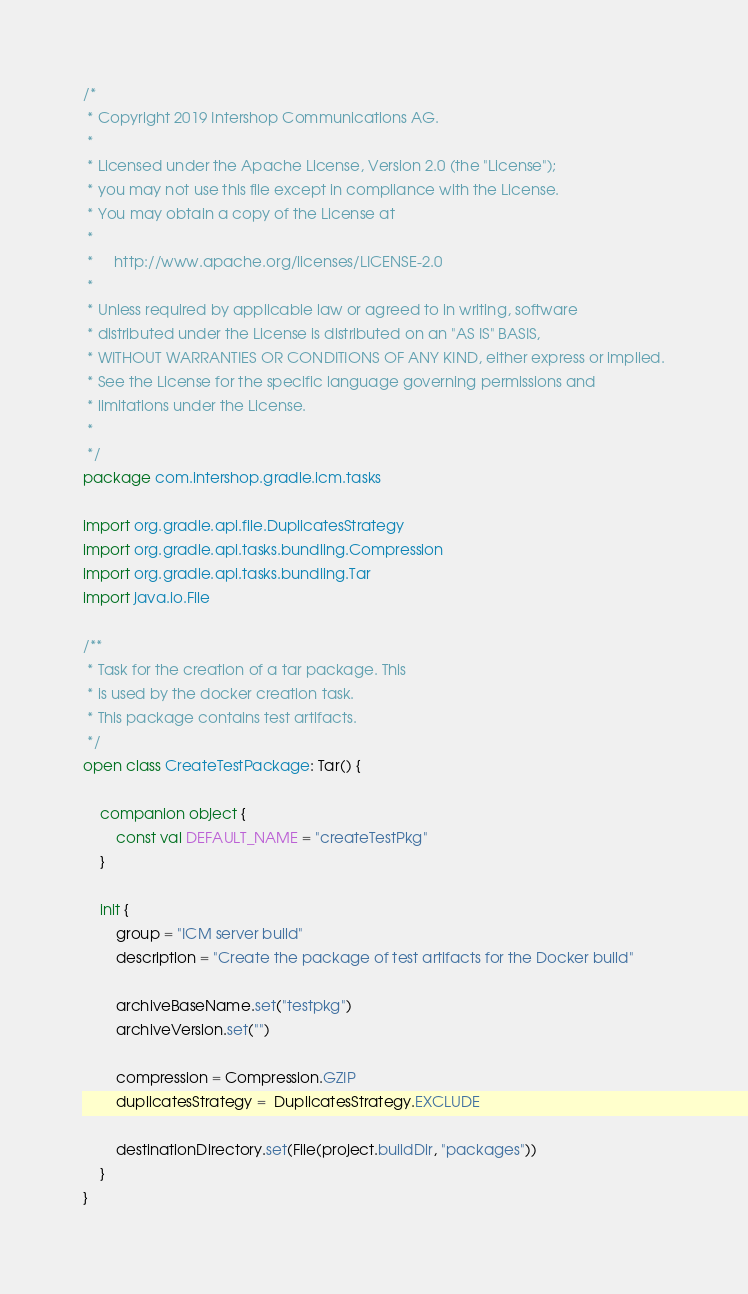<code> <loc_0><loc_0><loc_500><loc_500><_Kotlin_>/*
 * Copyright 2019 Intershop Communications AG.
 *
 * Licensed under the Apache License, Version 2.0 (the "License");
 * you may not use this file except in compliance with the License.
 * You may obtain a copy of the License at
 *
 *     http://www.apache.org/licenses/LICENSE-2.0
 *
 * Unless required by applicable law or agreed to in writing, software
 * distributed under the License is distributed on an "AS IS" BASIS,
 * WITHOUT WARRANTIES OR CONDITIONS OF ANY KIND, either express or implied.
 * See the License for the specific language governing permissions and
 * limitations under the License.
 *
 */
package com.intershop.gradle.icm.tasks

import org.gradle.api.file.DuplicatesStrategy
import org.gradle.api.tasks.bundling.Compression
import org.gradle.api.tasks.bundling.Tar
import java.io.File

/**
 * Task for the creation of a tar package. This
 * is used by the docker creation task.
 * This package contains test artifacts.
 */
open class CreateTestPackage: Tar() {

    companion object {
        const val DEFAULT_NAME = "createTestPkg"
    }

    init {
        group = "ICM server build"
        description = "Create the package of test artifacts for the Docker build"

        archiveBaseName.set("testpkg")
        archiveVersion.set("")

        compression = Compression.GZIP
        duplicatesStrategy =  DuplicatesStrategy.EXCLUDE

        destinationDirectory.set(File(project.buildDir, "packages"))
    }
}
</code> 